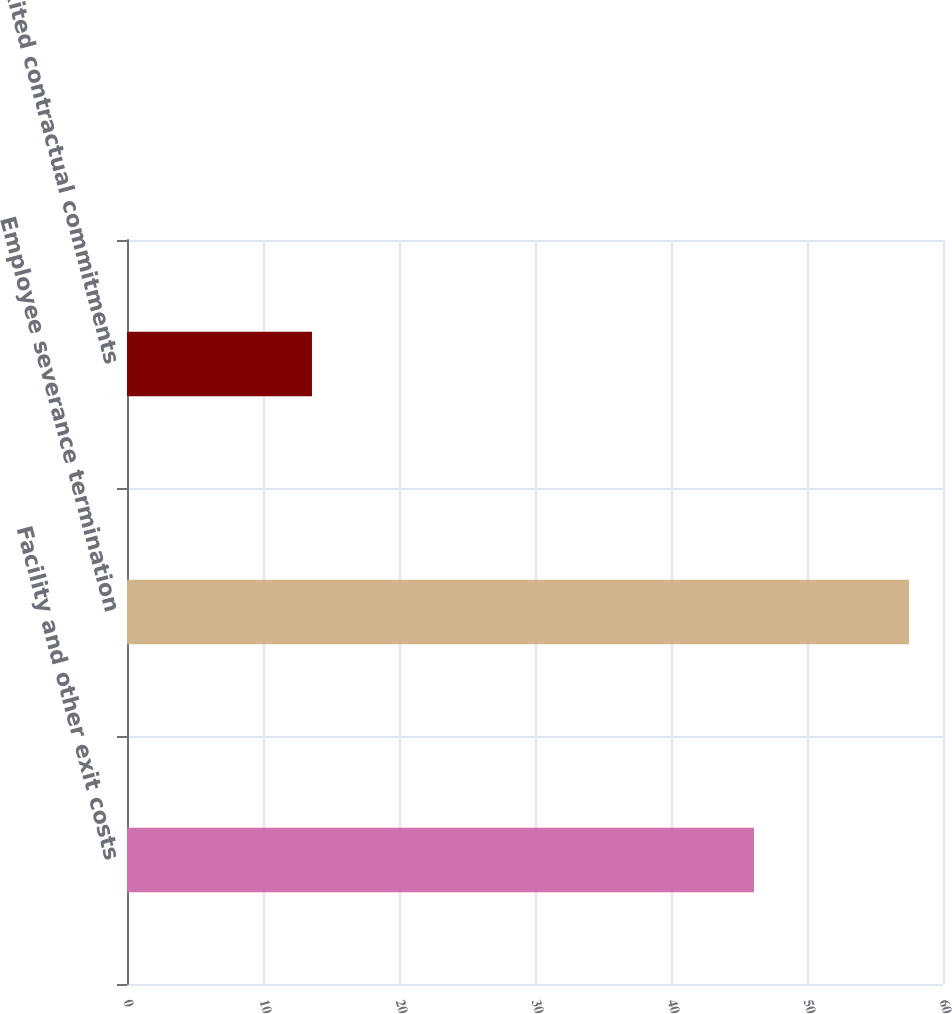Convert chart to OTSL. <chart><loc_0><loc_0><loc_500><loc_500><bar_chart><fcel>Facility and other exit costs<fcel>Employee severance termination<fcel>Exited contractual commitments<nl><fcel>46.1<fcel>57.5<fcel>13.6<nl></chart> 